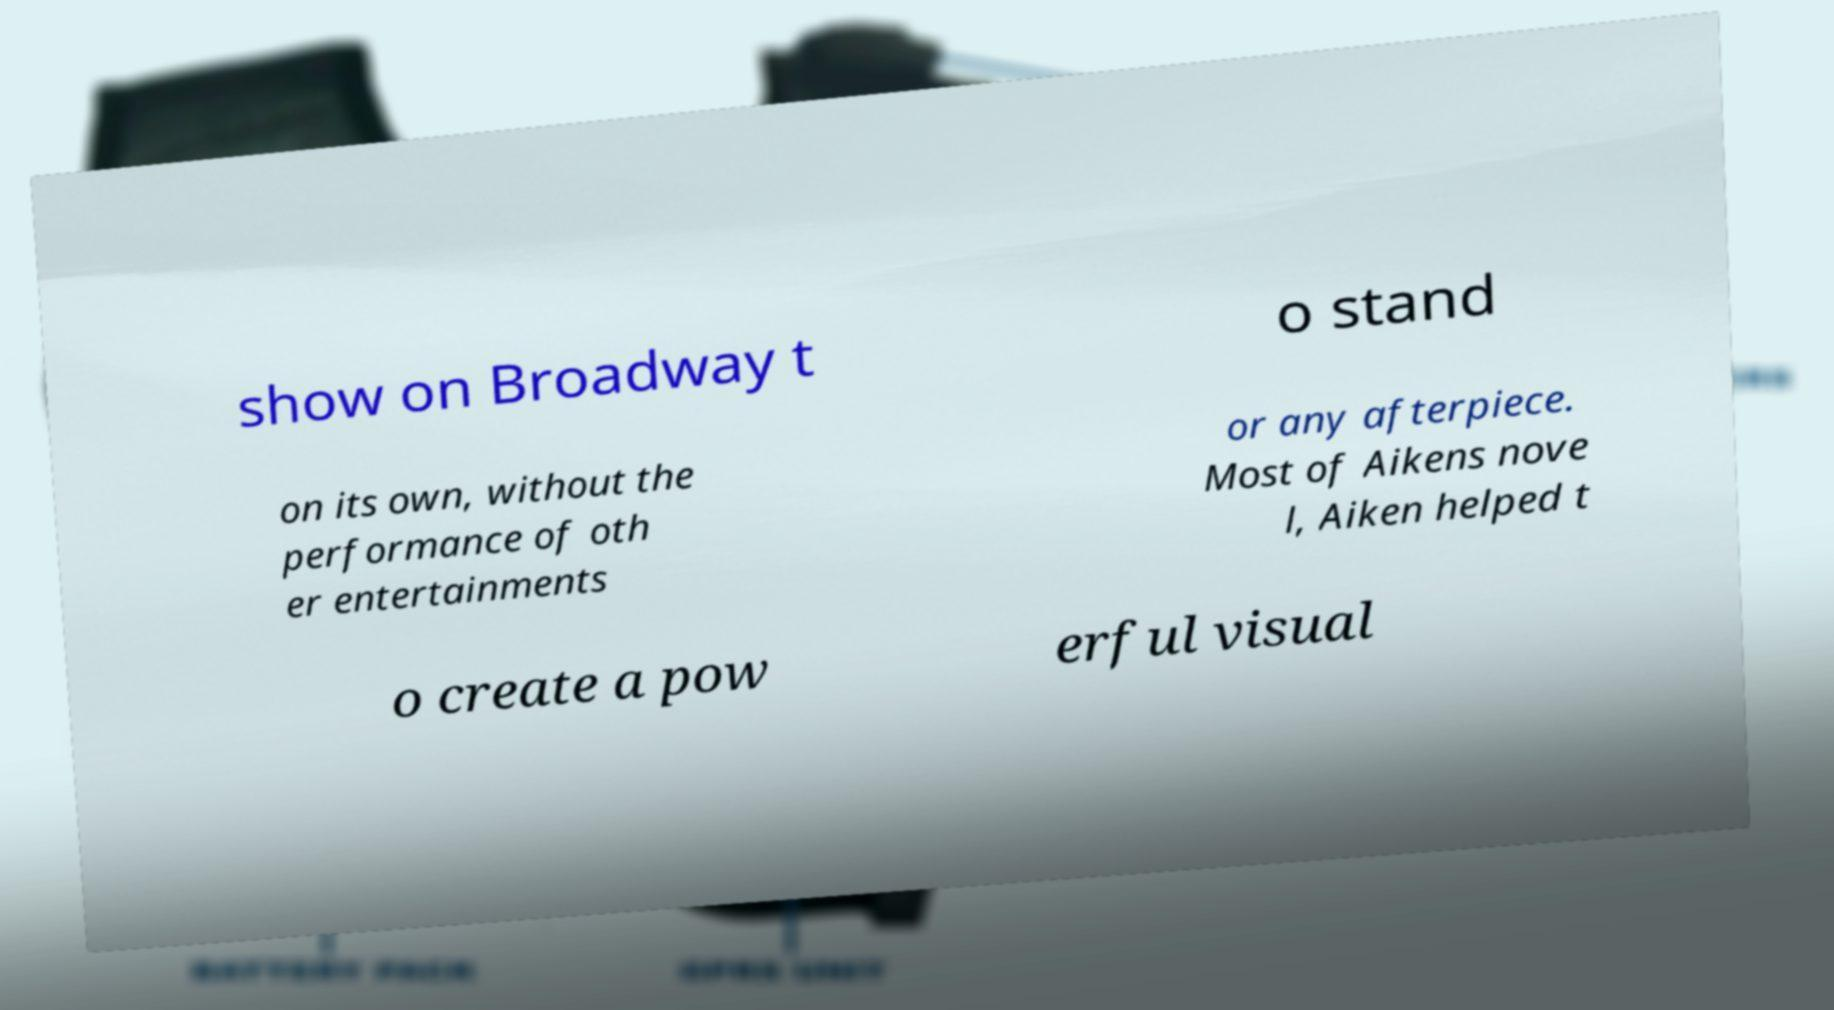There's text embedded in this image that I need extracted. Can you transcribe it verbatim? show on Broadway t o stand on its own, without the performance of oth er entertainments or any afterpiece. Most of Aikens nove l, Aiken helped t o create a pow erful visual 